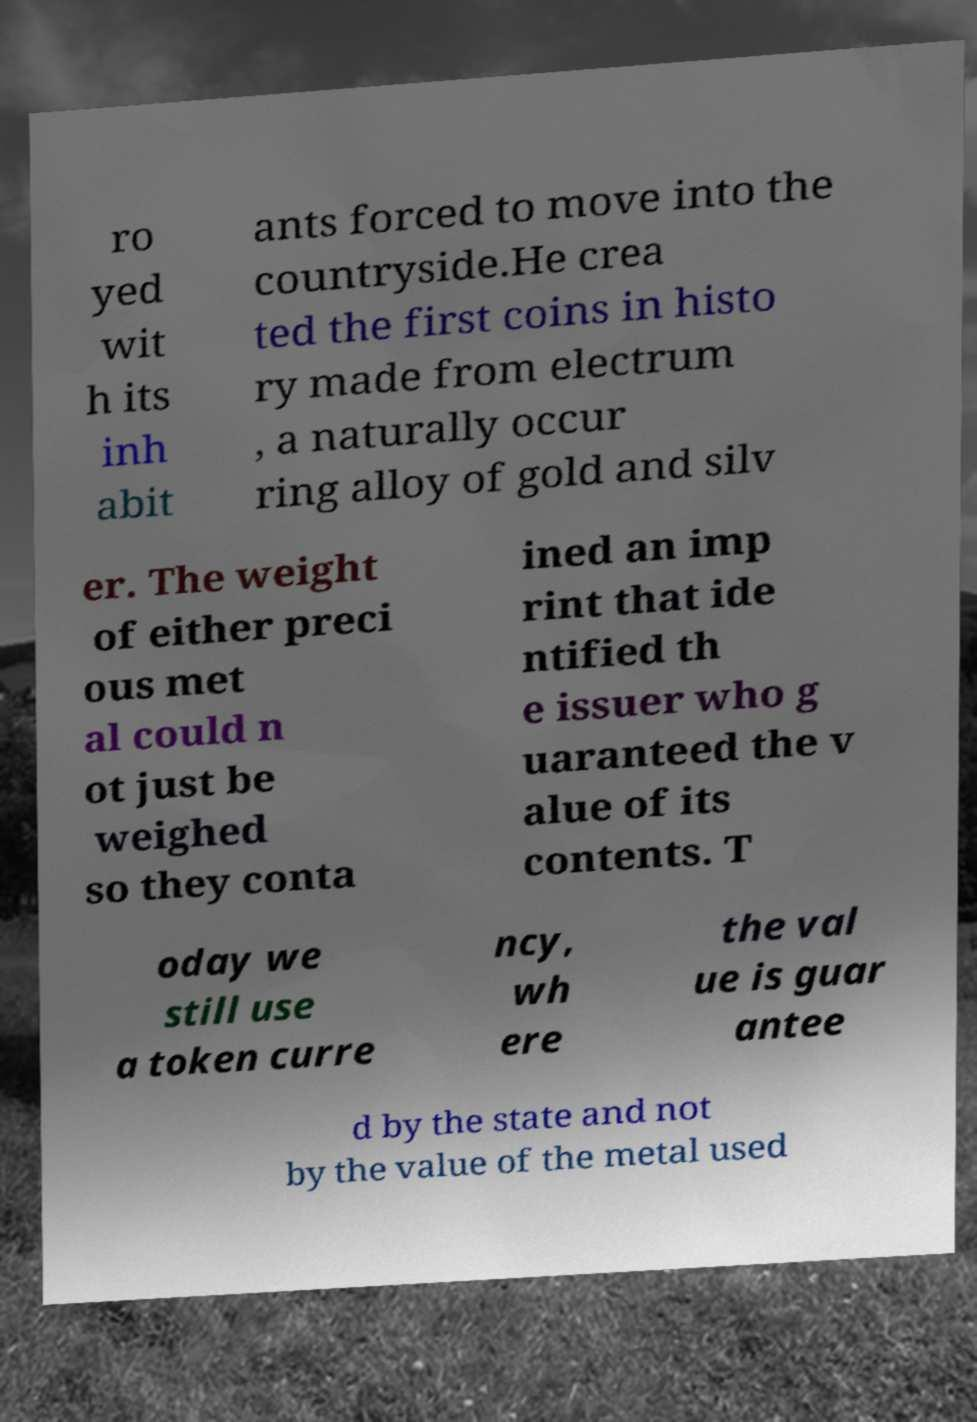Could you assist in decoding the text presented in this image and type it out clearly? ro yed wit h its inh abit ants forced to move into the countryside.He crea ted the first coins in histo ry made from electrum , a naturally occur ring alloy of gold and silv er. The weight of either preci ous met al could n ot just be weighed so they conta ined an imp rint that ide ntified th e issuer who g uaranteed the v alue of its contents. T oday we still use a token curre ncy, wh ere the val ue is guar antee d by the state and not by the value of the metal used 